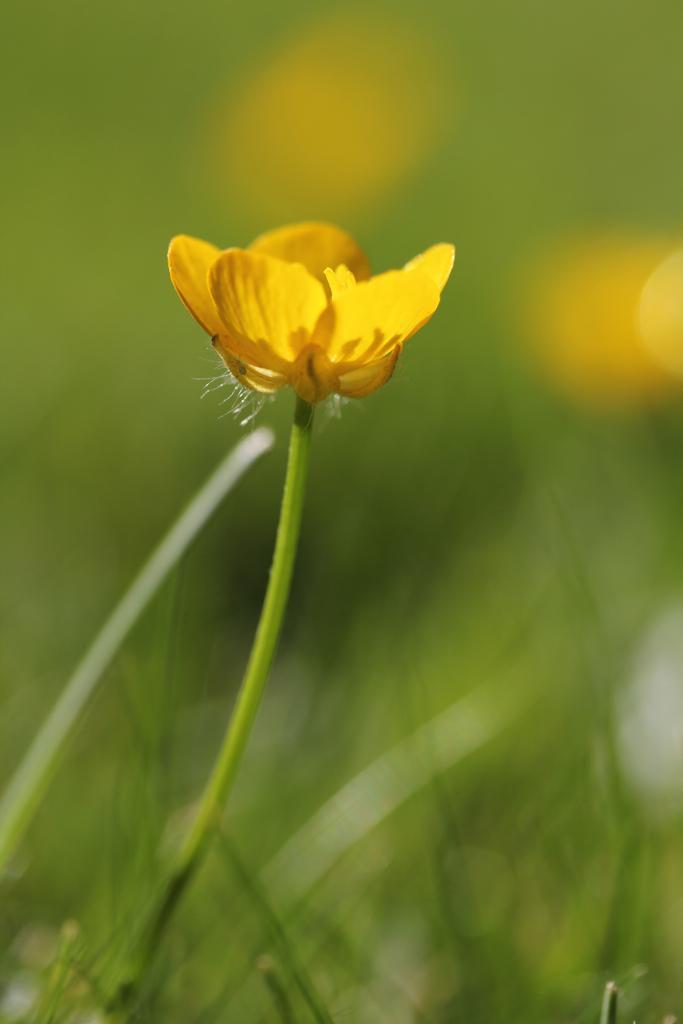How would you summarize this image in a sentence or two? In this picture we can see few flowers and blurry background. 